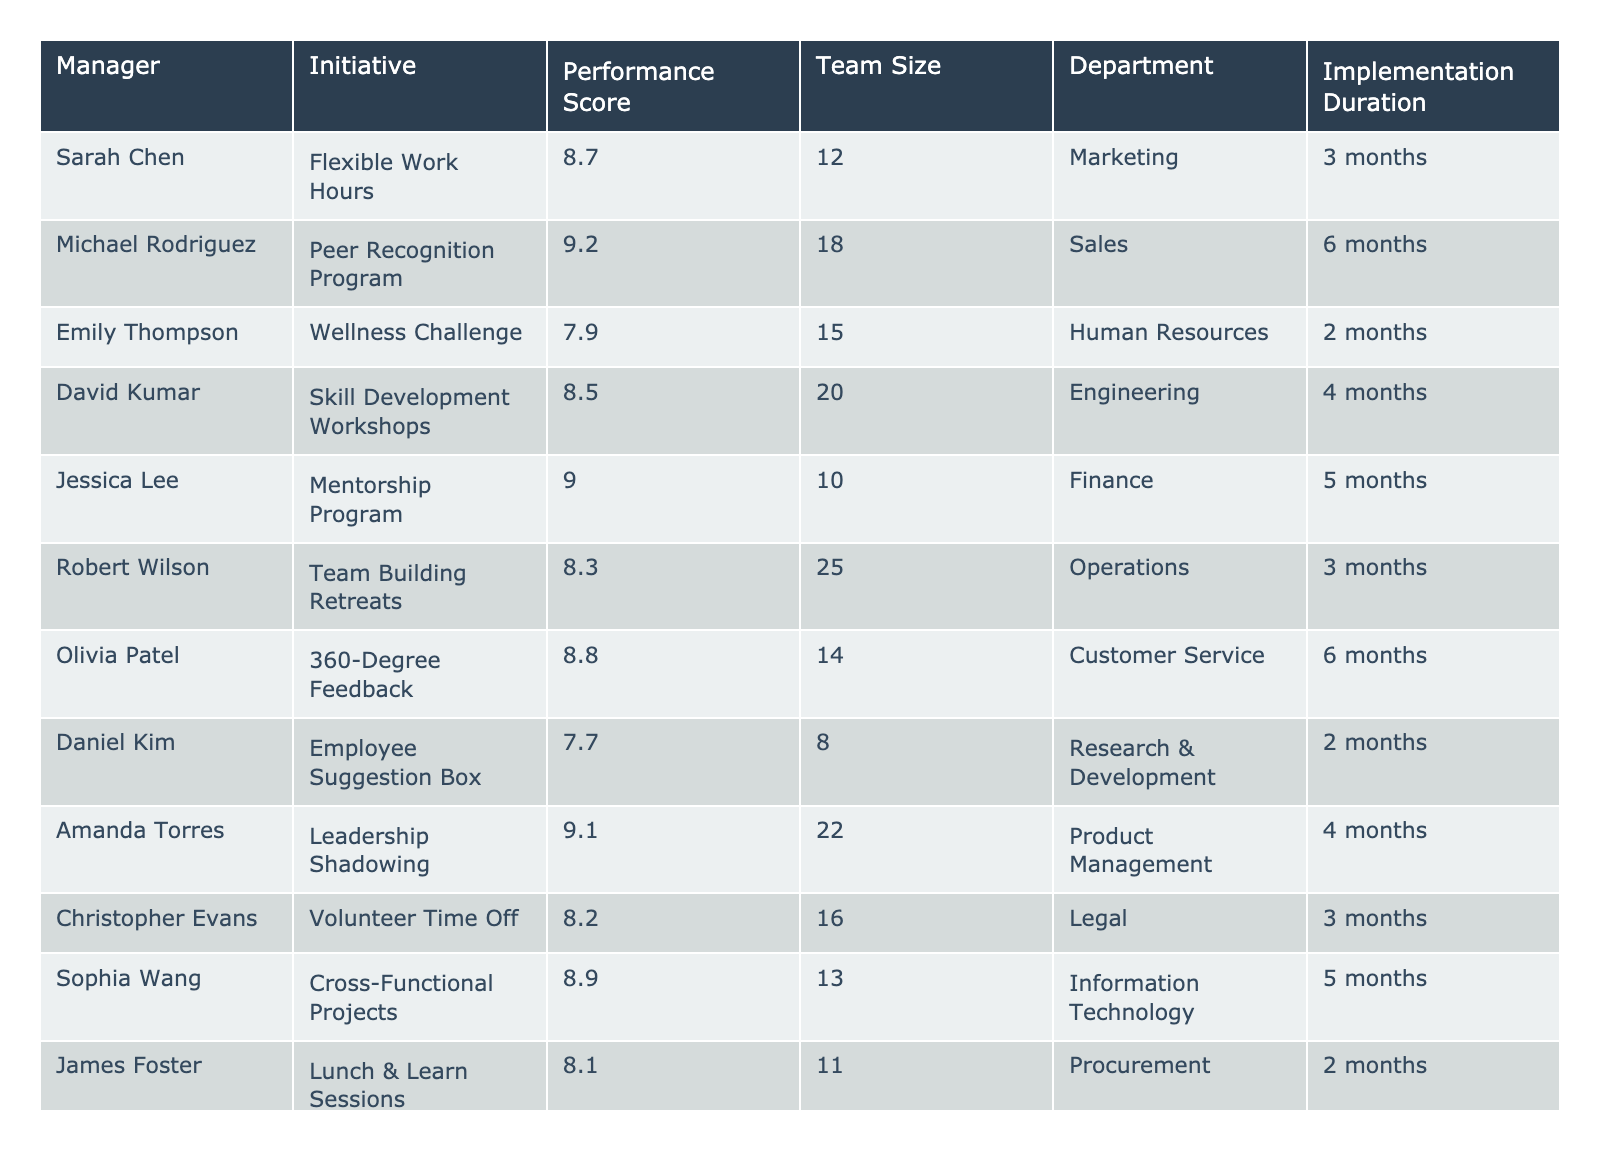What's the highest performance score among the managers? The highest performance score in the table is found by looking for the maximum value in the "Performance Score" column. The maximum score is 9.3, achieved by Ryan O'Connor.
Answer: 9.3 Which manager implemented the Employee Suggestion Box initiative? Referring to the "Initiative" column, the Employee Suggestion Box was implemented by Daniel Kim.
Answer: Daniel Kim What is the average performance score for the initiatives that have an implementation duration of 4 months? To find the average score, sum the scores of those initiatives with a duration of 4 months: (8.5 + 9.0 + 8.6 + 9.1) = 35.2, then divide by 4 (the number of initiatives): 35.2 / 4 = 8.8.
Answer: 8.8 Is there a manager in the Marketing department that achieved a performance score of 9 or higher? Checking the "Department" and "Performance Score" columns, Sarah Chen in Marketing achieved a score of 8.7, which is below 9. Thus, no manager in Marketing scored 9 or higher.
Answer: No How many managers implemented initiatives with a performance score below 8.5, and what are their names? We identify managers with scores below 8.5 by checking the "Performance Score" column. The managers are Daniel Kim (7.7), Emily Thompson (7.9), and Robert Wilson (8.3). There are 3 managers.
Answer: 3: Daniel Kim, Emily Thompson, Robert Wilson What is the performance score related to the Team Building Retreats initiative? By locating the "Initiative" value "Team Building Retreats" in the table, we can see that the corresponding performance score is 8.3.
Answer: 8.3 Which department had the highest-performing initiative based on performance score, and what was that score? The department with the highest performance score is Software Development, led by Ryan O'Connor with a score of 9.3.
Answer: Software Development, 9.3 Calculate the difference in performance scores between the highest and lowest scores in the table. The highest score is 9.3 and the lowest is 7.7. Therefore, the difference is calculated as 9.3 - 7.7 = 1.6.
Answer: 1.6 Which two initiatives tied for the closest performance scores below 9? The closest scores below 9 are 8.9 (Cross-Functional Projects) and 8.8 (360-Degree Feedback), thus those are the two initiatives.
Answer: Cross-Functional Projects, 360-Degree Feedback How many departments have an initiative with a performance score of 9 or higher? Checking the scores, we find managers from 4 different departments—Sales, Product Management, and Software Development—have initiatives with a score of 9 or higher.
Answer: 4 What was the implementation duration of the Peer Recognition Program? By looking at the "Initiative" column for Peer Recognition Program, it has an implementation duration of 6 months.
Answer: 6 months 